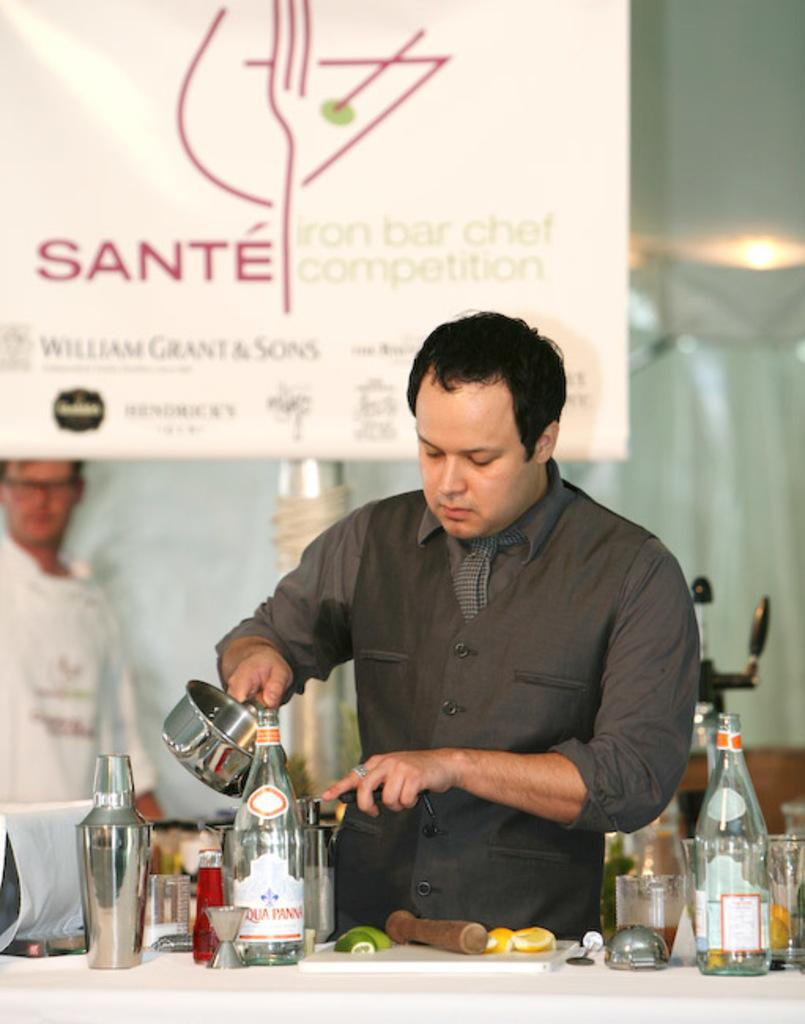<image>
Give a short and clear explanation of the subsequent image. Sante iron bar chef competition is on display by way of a banner behind a chef in a gray outfit. 